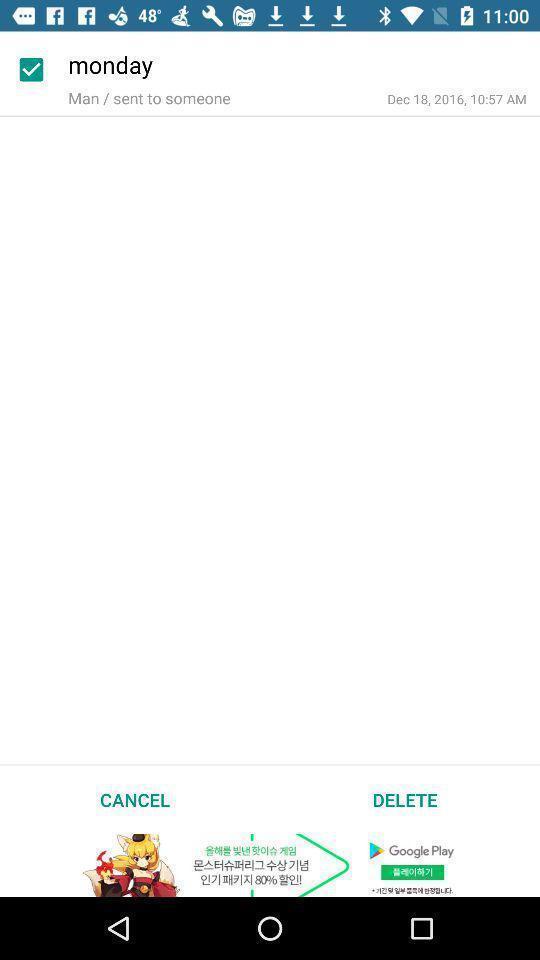What is the overall content of this screenshot? Page of monday sent to some one. 